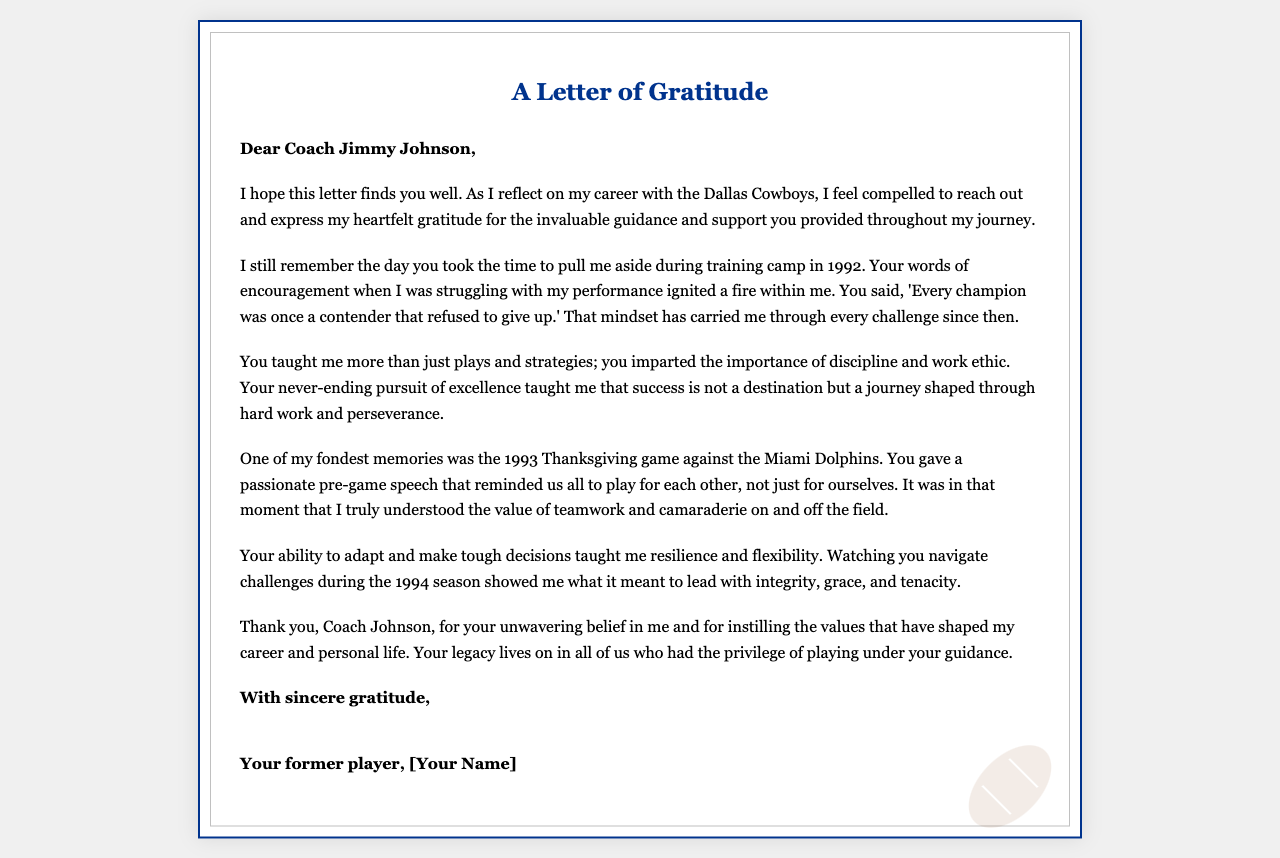What is the name of the coach? The document mentions the coach by name, which is Jimmy Johnson.
Answer: Jimmy Johnson In what year did the player remember the training camp with the coach? The letter specifies that the player remembers the training camp in 1992.
Answer: 1992 What memorable game is highlighted in the letter? The letter refers specifically to the 1993 Thanksgiving game against the Miami Dolphins.
Answer: Thanksgiving game against the Miami Dolphins What key lesson did the coach teach the player about success? The letter states that success is not a destination but a journey shaped through hard work and perseverance.
Answer: Success is a journey What was the player's sentiment towards the coach's influence on their career? The player expresses gratitude for the coach's unwavering belief and the values instilled that shaped their career.
Answer: Heartfelt gratitude What does the player address the coach as in the letter? The letter begins with a formal salutation addressing the coach as "Dear Coach Jimmy Johnson."
Answer: Dear Coach Jimmy Johnson What critical skill did the player learn from the coach regarding leadership? The player learned resilience and flexibility from the coach's ability to adapt and make tough decisions.
Answer: Resilience and flexibility What is the tone of the letter? The tone of the letter is one of gratitude and respect towards the coach for their guidance.
Answer: Gratitude and respect 